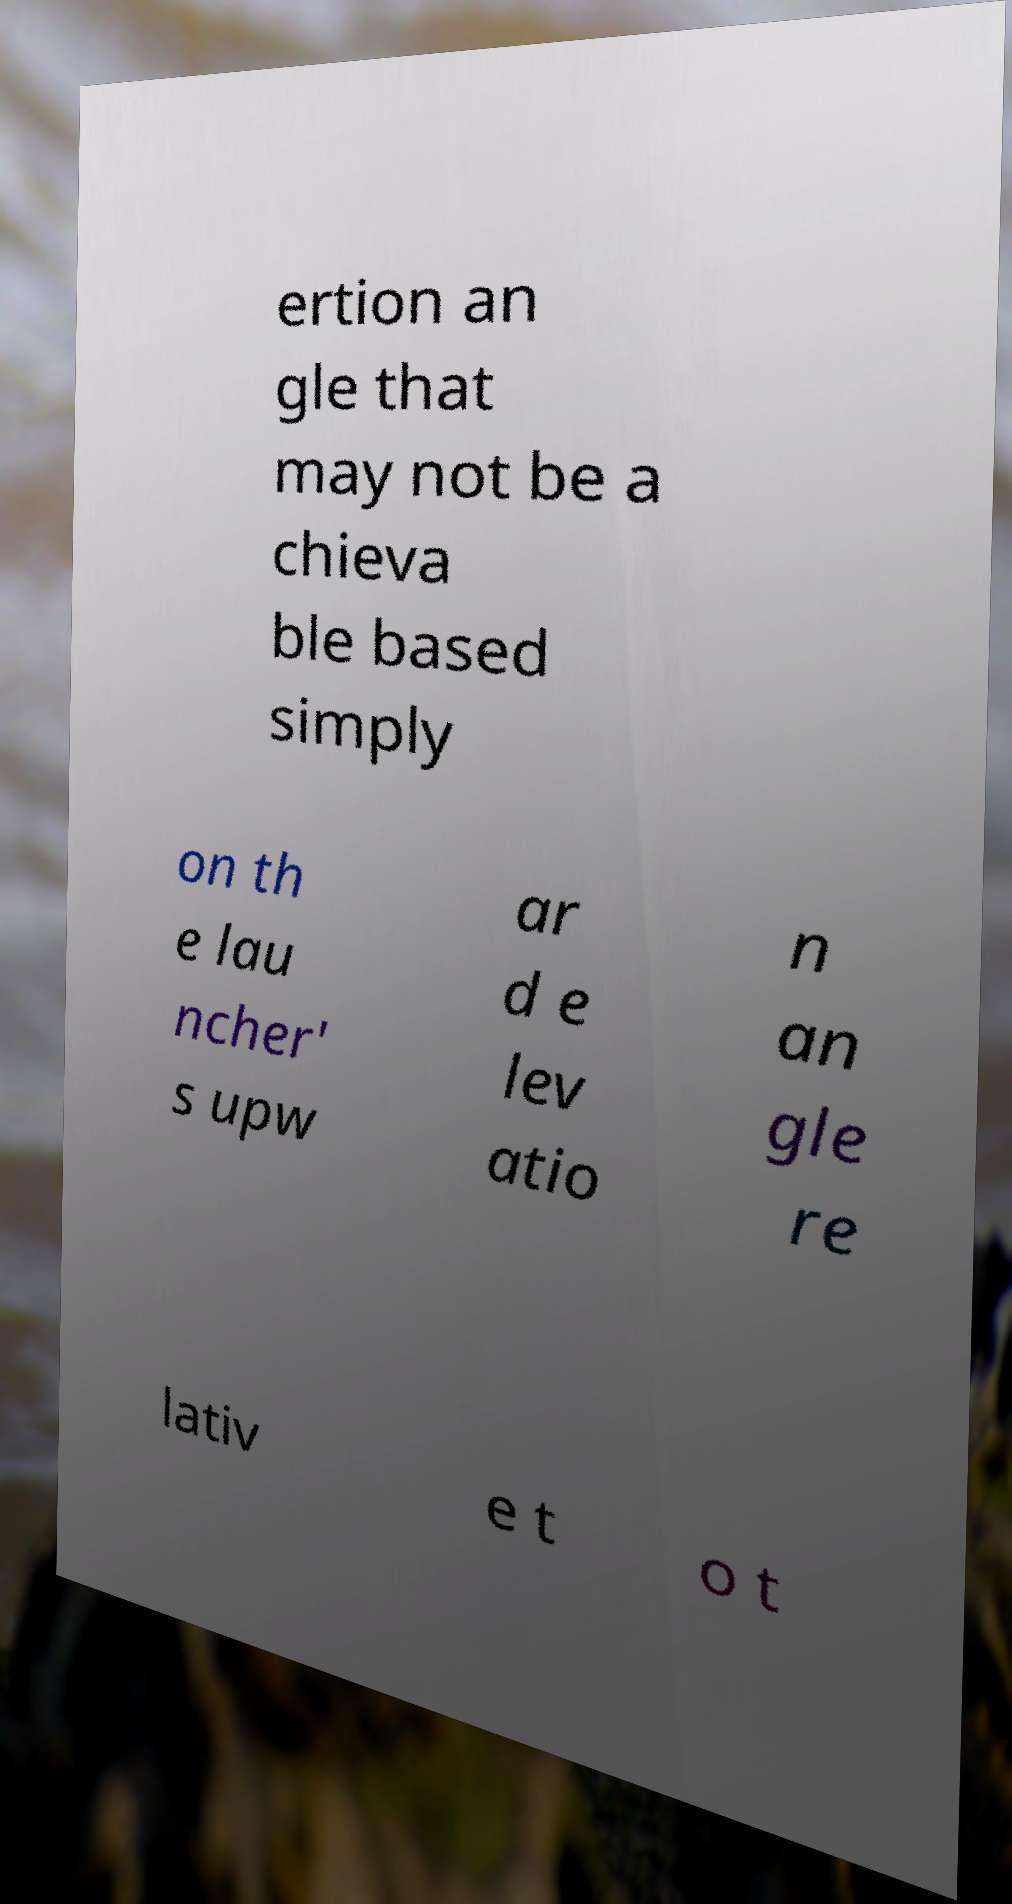What messages or text are displayed in this image? I need them in a readable, typed format. ertion an gle that may not be a chieva ble based simply on th e lau ncher' s upw ar d e lev atio n an gle re lativ e t o t 